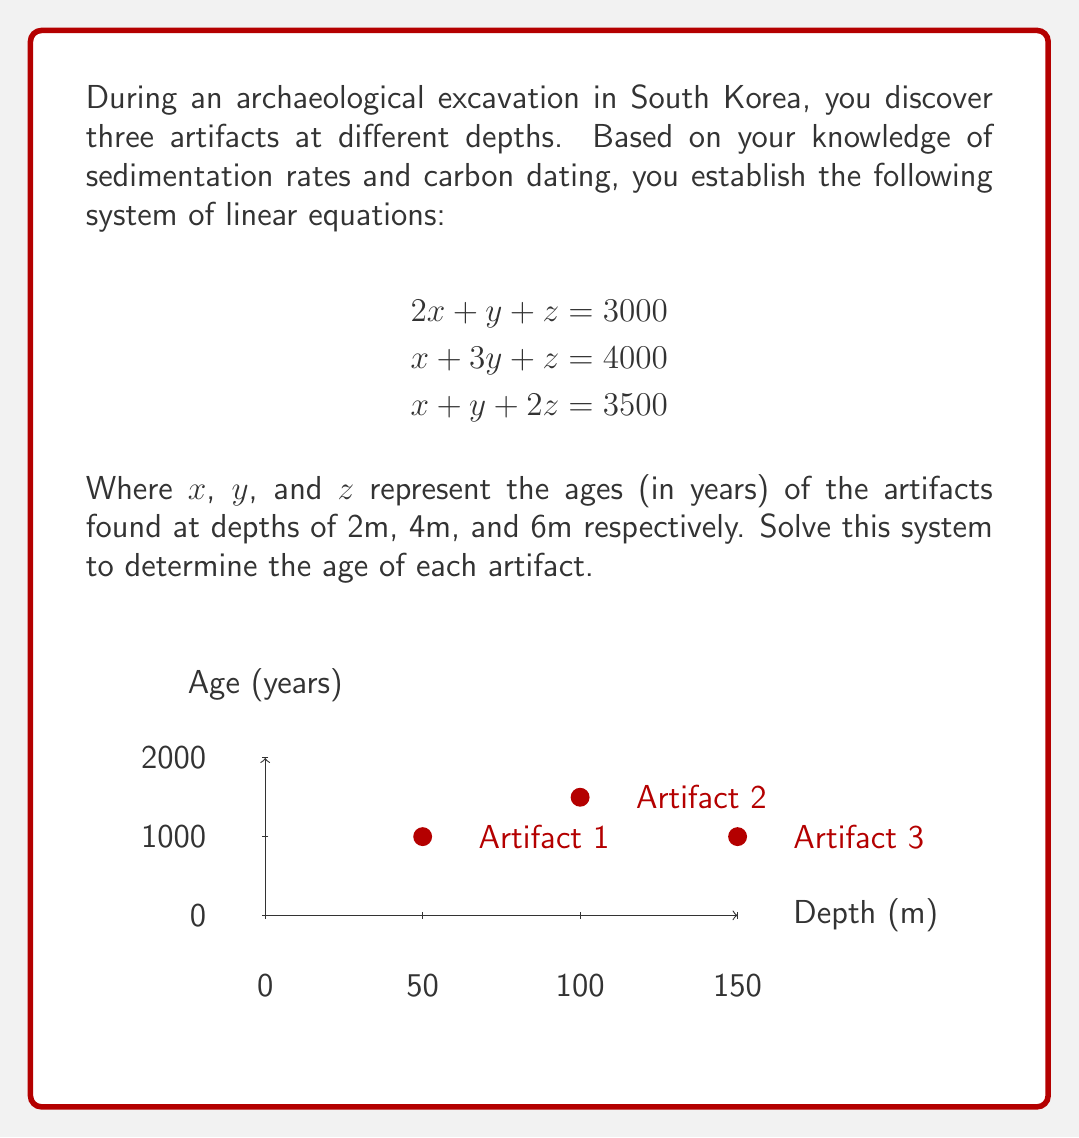Show me your answer to this math problem. To solve this system of linear equations, we'll use the Gaussian elimination method:

1) First, write the augmented matrix:

$$\begin{bmatrix}
2 & 1 & 1 & | & 3000 \\
1 & 3 & 1 & | & 4000 \\
1 & 1 & 2 & | & 3500
\end{bmatrix}$$

2) Subtract row 1 from row 2 and row 3:

$$\begin{bmatrix}
2 & 1 & 1 & | & 3000 \\
-1 & 2 & 0 & | & 1000 \\
-1 & 0 & 1 & | & 500
\end{bmatrix}$$

3) Add row 2 to row 1:

$$\begin{bmatrix}
1 & 3 & 1 & | & 4000 \\
-1 & 2 & 0 & | & 1000 \\
-1 & 0 & 1 & | & 500
\end{bmatrix}$$

4) Add row 1 to row 2 and row 3:

$$\begin{bmatrix}
1 & 3 & 1 & | & 4000 \\
0 & 5 & 1 & | & 5000 \\
0 & 3 & 2 & | & 4500
\end{bmatrix}$$

5) Subtract 3/5 of row 2 from row 3:

$$\begin{bmatrix}
1 & 3 & 1 & | & 4000 \\
0 & 5 & 1 & | & 5000 \\
0 & 0 & 1.4 & | & 1500
\end{bmatrix}$$

6) Divide the last row by 1.4:

$$\begin{bmatrix}
1 & 3 & 1 & | & 4000 \\
0 & 5 & 1 & | & 5000 \\
0 & 0 & 1 & | & 1000
\end{bmatrix}$$

7) Now we can solve by back-substitution:

$z = 1000$

$5y + 1000 = 5000$, so $y = 800$

$x + 3(800) + 1000 = 4000$, so $x = 1000$

Therefore, the ages of the artifacts are:
$x = 1000$ years (2m depth)
$y = 800$ years (4m depth)
$z = 1000$ years (6m depth)
Answer: $x = 1000$, $y = 800$, $z = 1000$ (years) 